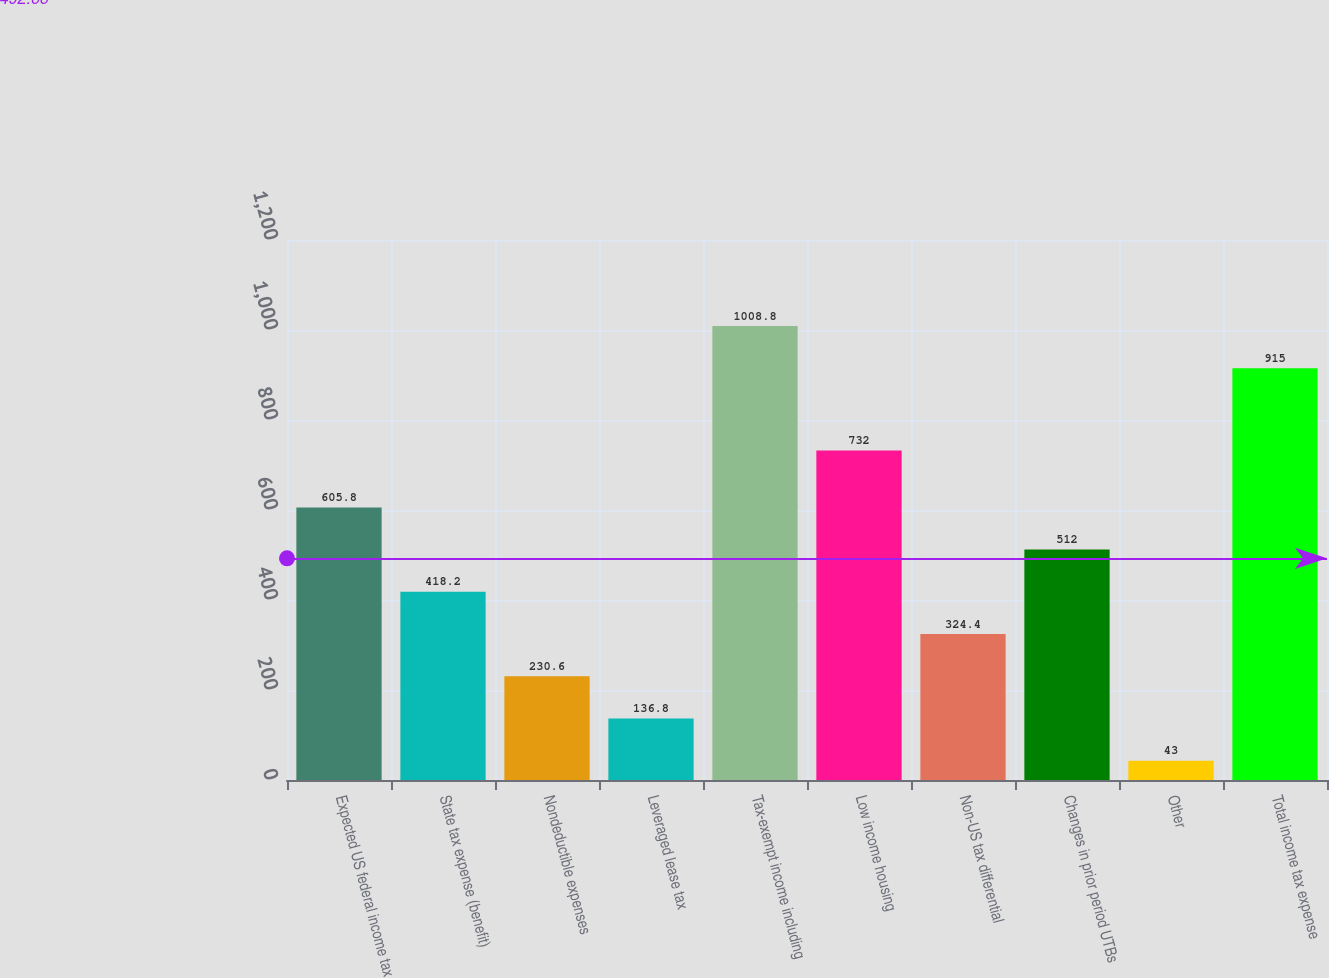Convert chart to OTSL. <chart><loc_0><loc_0><loc_500><loc_500><bar_chart><fcel>Expected US federal income tax<fcel>State tax expense (benefit)<fcel>Nondeductible expenses<fcel>Leveraged lease tax<fcel>Tax-exempt income including<fcel>Low income housing<fcel>Non-US tax differential<fcel>Changes in prior period UTBs<fcel>Other<fcel>Total income tax expense<nl><fcel>605.8<fcel>418.2<fcel>230.6<fcel>136.8<fcel>1008.8<fcel>732<fcel>324.4<fcel>512<fcel>43<fcel>915<nl></chart> 